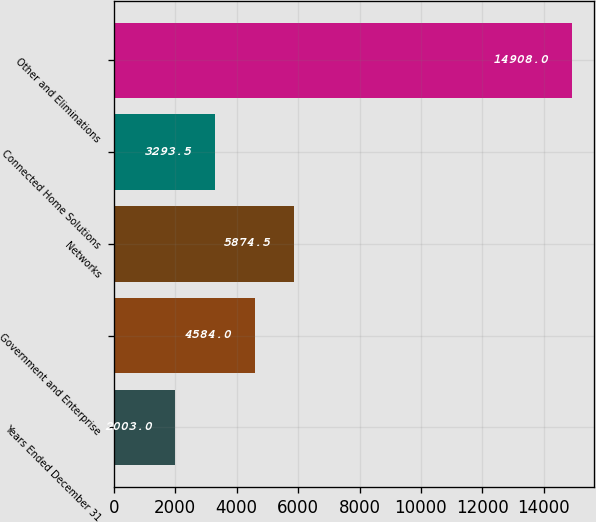Convert chart. <chart><loc_0><loc_0><loc_500><loc_500><bar_chart><fcel>Years Ended December 31<fcel>Government and Enterprise<fcel>Networks<fcel>Connected Home Solutions<fcel>Other and Eliminations<nl><fcel>2003<fcel>4584<fcel>5874.5<fcel>3293.5<fcel>14908<nl></chart> 